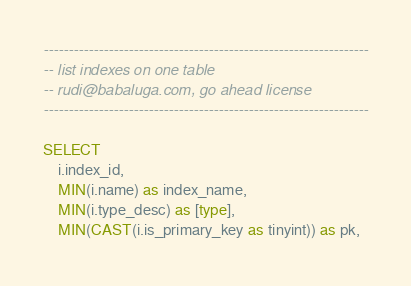<code> <loc_0><loc_0><loc_500><loc_500><_SQL_>-----------------------------------------------------------------
-- list indexes on one table
-- rudi@babaluga.com, go ahead license
-----------------------------------------------------------------

SELECT 
	i.index_id,
	MIN(i.name) as index_name,
	MIN(i.type_desc) as [type],
	MIN(CAST(i.is_primary_key as tinyint)) as pk,</code> 